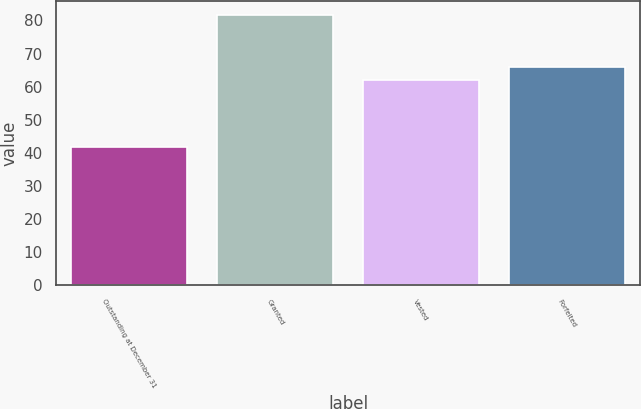Convert chart to OTSL. <chart><loc_0><loc_0><loc_500><loc_500><bar_chart><fcel>Outstanding at December 31<fcel>Granted<fcel>Vested<fcel>Forfeited<nl><fcel>41.87<fcel>81.7<fcel>61.95<fcel>65.93<nl></chart> 